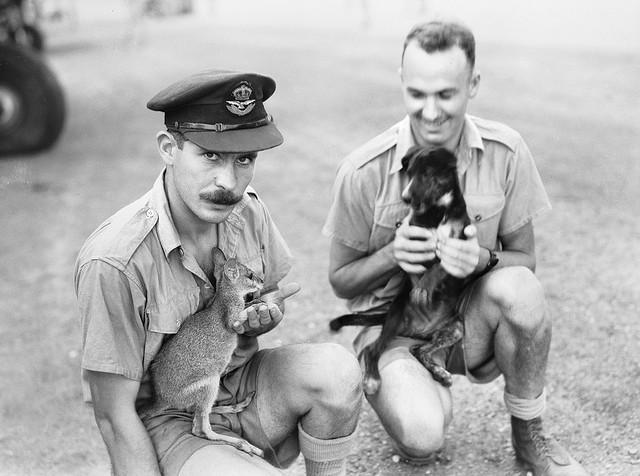How many people are in the picture?
Give a very brief answer. 2. How many cars are on the street?
Give a very brief answer. 0. 